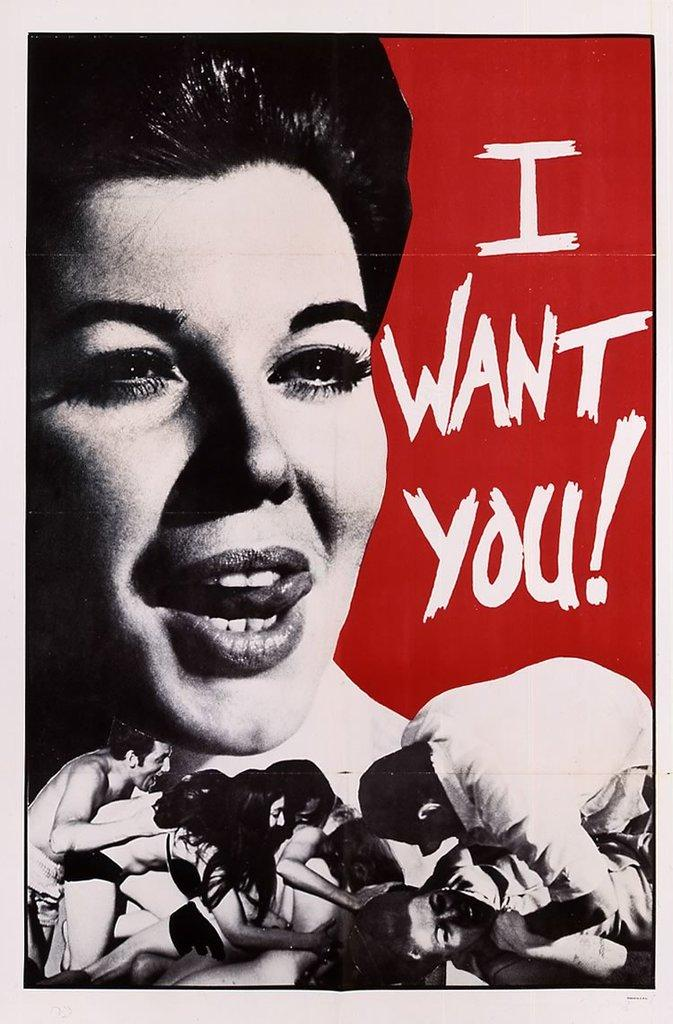Provide a one-sentence caption for the provided image. Sexually explicit photo cover with the words "I Want You!" on the right. 